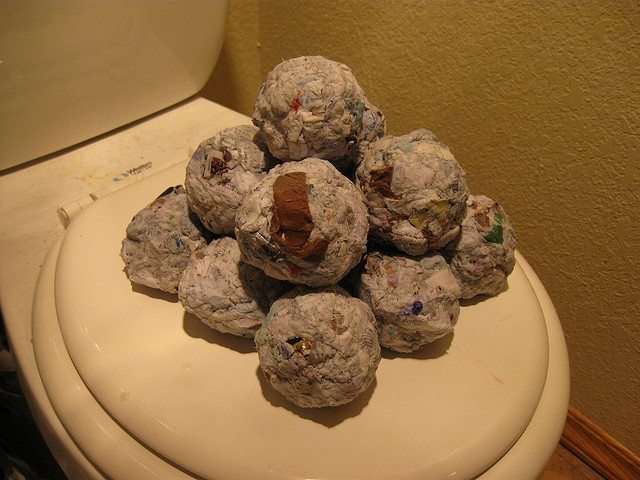Describe the objects in this image and their specific colors. I can see a toilet in olive and tan tones in this image. 